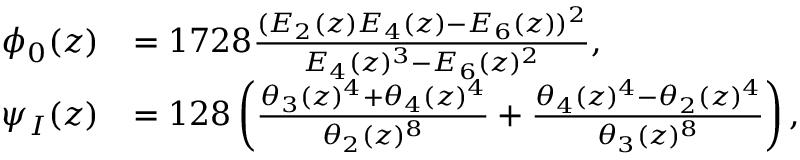Convert formula to latex. <formula><loc_0><loc_0><loc_500><loc_500>\begin{array} { r l } { \phi _ { 0 } ( z ) } & { = 1 7 2 8 \frac { ( E _ { 2 } ( z ) E _ { 4 } ( z ) - E _ { 6 } ( z ) ) ^ { 2 } } { E _ { 4 } ( z ) ^ { 3 } - E _ { 6 } ( z ) ^ { 2 } } , } \\ { \psi _ { I } ( z ) } & { = 1 2 8 \left ( \frac { \theta _ { 3 } ( z ) ^ { 4 } + \theta _ { 4 } ( z ) ^ { 4 } } { \theta _ { 2 } ( z ) ^ { 8 } } + \frac { \theta _ { 4 } ( z ) ^ { 4 } - \theta _ { 2 } ( z ) ^ { 4 } } { \theta _ { 3 } ( z ) ^ { 8 } } \right ) , } \end{array}</formula> 